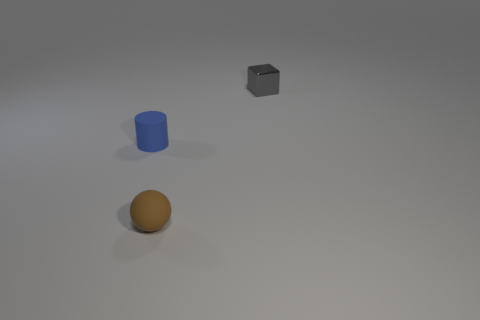What number of cylinders are either small matte objects or small brown objects?
Your answer should be compact. 1. What shape is the blue rubber thing?
Your answer should be very brief. Cylinder. Are there any gray shiny objects left of the cylinder?
Keep it short and to the point. No. Are the blue object and the small object in front of the blue thing made of the same material?
Provide a short and direct response. Yes. There is a rubber object that is behind the tiny brown sphere; is it the same shape as the tiny brown thing?
Provide a succinct answer. No. How many blue objects are the same material as the blue cylinder?
Offer a terse response. 0. How many objects are objects behind the blue cylinder or big red balls?
Provide a succinct answer. 1. What size is the blue object?
Offer a very short reply. Small. The small object that is right of the small rubber object on the right side of the small blue rubber cylinder is made of what material?
Provide a short and direct response. Metal. Does the matte thing in front of the blue object have the same size as the small blue cylinder?
Provide a succinct answer. Yes. 